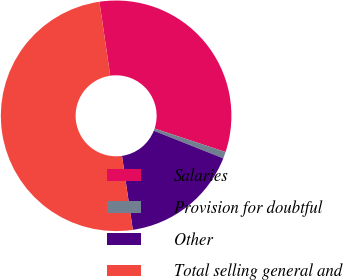Convert chart. <chart><loc_0><loc_0><loc_500><loc_500><pie_chart><fcel>Salaries<fcel>Provision for doubtful<fcel>Other<fcel>Total selling general and<nl><fcel>32.41%<fcel>0.93%<fcel>16.67%<fcel>50.0%<nl></chart> 